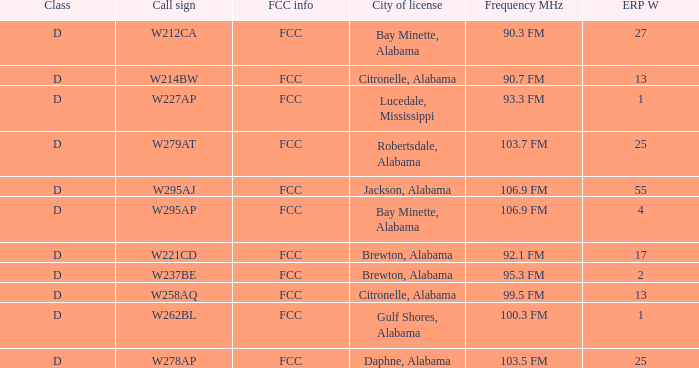Name the call sign for ERP W of 4 W295AP. 